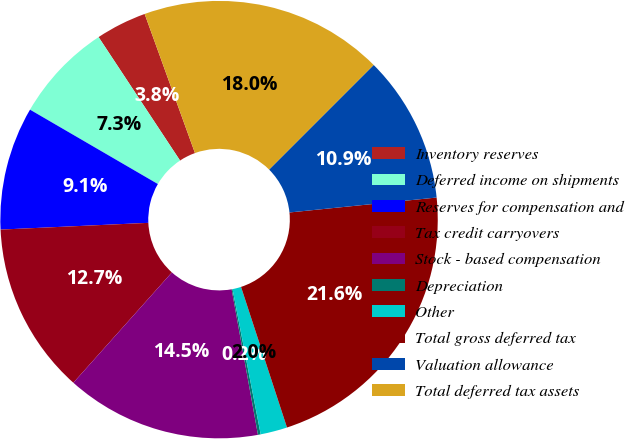Convert chart. <chart><loc_0><loc_0><loc_500><loc_500><pie_chart><fcel>Inventory reserves<fcel>Deferred income on shipments<fcel>Reserves for compensation and<fcel>Tax credit carryovers<fcel>Stock - based compensation<fcel>Depreciation<fcel>Other<fcel>Total gross deferred tax<fcel>Valuation allowance<fcel>Total deferred tax assets<nl><fcel>3.76%<fcel>7.33%<fcel>9.11%<fcel>12.67%<fcel>14.45%<fcel>0.2%<fcel>1.98%<fcel>21.58%<fcel>10.89%<fcel>18.02%<nl></chart> 